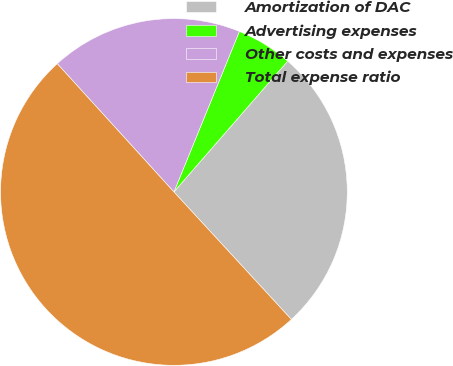Convert chart. <chart><loc_0><loc_0><loc_500><loc_500><pie_chart><fcel>Amortization of DAC<fcel>Advertising expenses<fcel>Other costs and expenses<fcel>Total expense ratio<nl><fcel>26.76%<fcel>5.23%<fcel>17.91%<fcel>50.1%<nl></chart> 